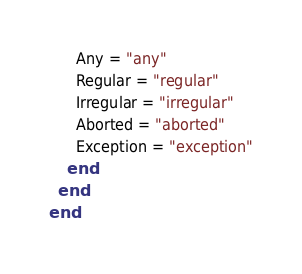Convert code to text. <code><loc_0><loc_0><loc_500><loc_500><_Ruby_>      Any = "any"
      Regular = "regular"
      Irregular = "irregular"
      Aborted = "aborted"
      Exception = "exception"
    end
  end
end
</code> 